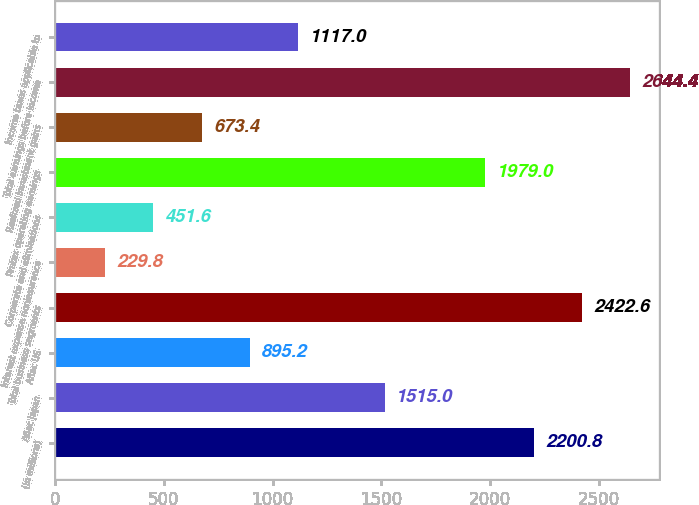Convert chart to OTSL. <chart><loc_0><loc_0><loc_500><loc_500><bar_chart><fcel>(In millions)<fcel>Aflac Japan<fcel>Aflac US<fcel>Total business segments<fcel>Interest expense noninsurance<fcel>Corporate and eliminations<fcel>Pretax operating earnings<fcel>Realized investment gains<fcel>Total earnings before income<fcel>Income taxes applicable to<nl><fcel>2200.8<fcel>1515<fcel>895.2<fcel>2422.6<fcel>229.8<fcel>451.6<fcel>1979<fcel>673.4<fcel>2644.4<fcel>1117<nl></chart> 